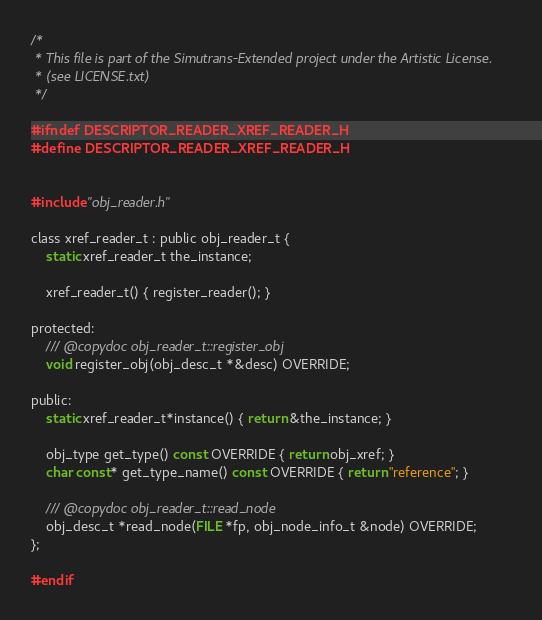<code> <loc_0><loc_0><loc_500><loc_500><_C_>/*
 * This file is part of the Simutrans-Extended project under the Artistic License.
 * (see LICENSE.txt)
 */

#ifndef DESCRIPTOR_READER_XREF_READER_H
#define DESCRIPTOR_READER_XREF_READER_H


#include "obj_reader.h"

class xref_reader_t : public obj_reader_t {
	static xref_reader_t the_instance;

	xref_reader_t() { register_reader(); }

protected:
	/// @copydoc obj_reader_t::register_obj
	void register_obj(obj_desc_t *&desc) OVERRIDE;

public:
	static xref_reader_t*instance() { return &the_instance; }

	obj_type get_type() const OVERRIDE { return obj_xref; }
	char const* get_type_name() const OVERRIDE { return "reference"; }

	/// @copydoc obj_reader_t::read_node
	obj_desc_t *read_node(FILE *fp, obj_node_info_t &node) OVERRIDE;
};

#endif
</code> 